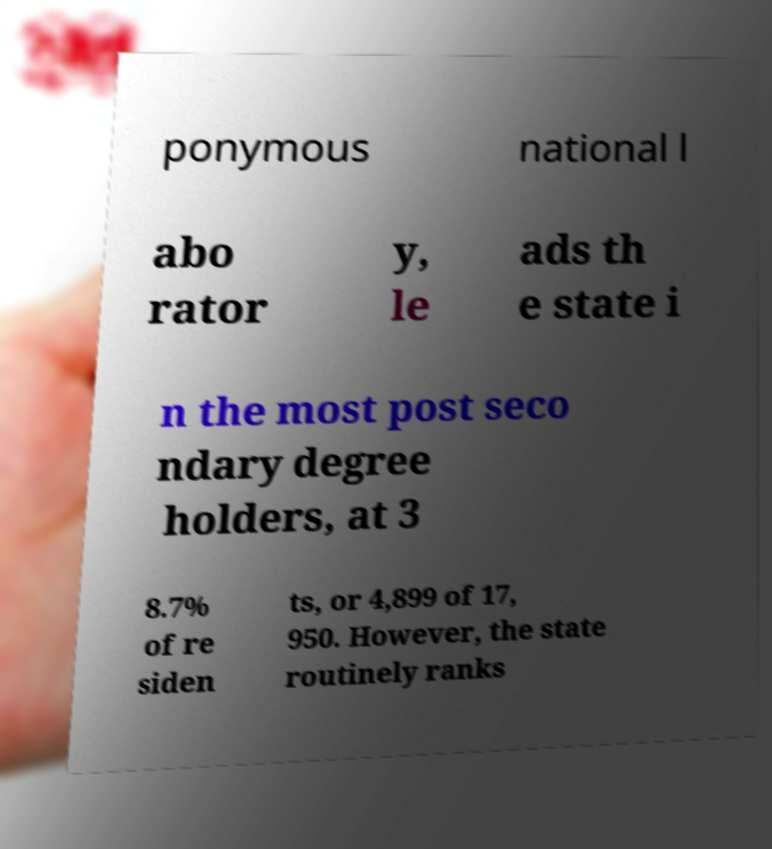Can you accurately transcribe the text from the provided image for me? ponymous national l abo rator y, le ads th e state i n the most post seco ndary degree holders, at 3 8.7% of re siden ts, or 4,899 of 17, 950. However, the state routinely ranks 